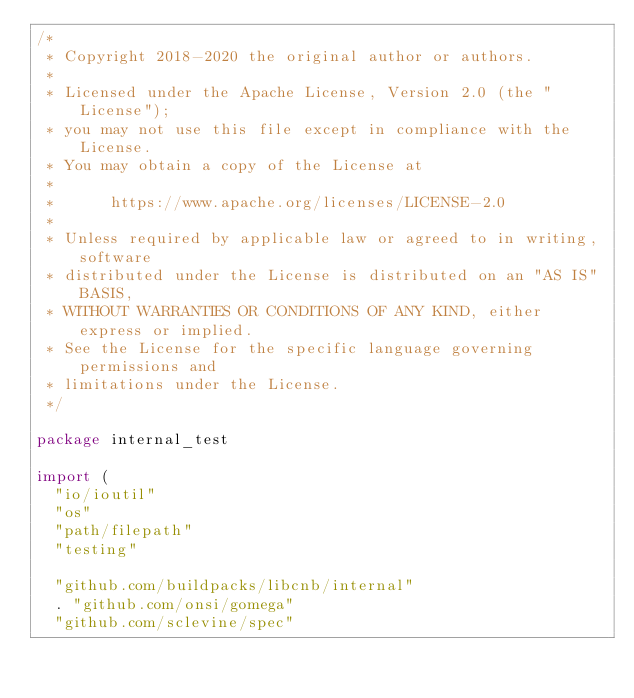<code> <loc_0><loc_0><loc_500><loc_500><_Go_>/*
 * Copyright 2018-2020 the original author or authors.
 *
 * Licensed under the Apache License, Version 2.0 (the "License");
 * you may not use this file except in compliance with the License.
 * You may obtain a copy of the License at
 *
 *      https://www.apache.org/licenses/LICENSE-2.0
 *
 * Unless required by applicable law or agreed to in writing, software
 * distributed under the License is distributed on an "AS IS" BASIS,
 * WITHOUT WARRANTIES OR CONDITIONS OF ANY KIND, either express or implied.
 * See the License for the specific language governing permissions and
 * limitations under the License.
 */

package internal_test

import (
	"io/ioutil"
	"os"
	"path/filepath"
	"testing"

	"github.com/buildpacks/libcnb/internal"
	. "github.com/onsi/gomega"
	"github.com/sclevine/spec"</code> 